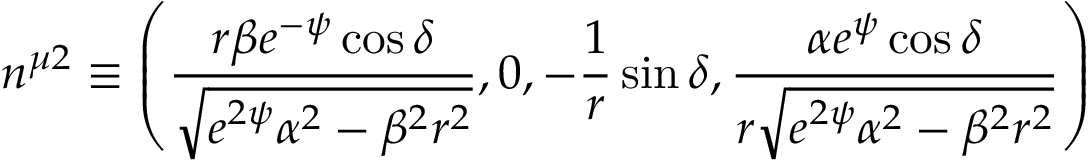Convert formula to latex. <formula><loc_0><loc_0><loc_500><loc_500>n ^ { \mu 2 } \equiv \left ( \frac { r \beta e ^ { - \psi } \cos \delta } { \sqrt { e ^ { 2 \psi } \alpha ^ { 2 } - \beta ^ { 2 } r ^ { 2 } } } , 0 , - \frac { 1 } { r } \sin \delta , \frac { \alpha e ^ { \psi } \cos \delta } { r \sqrt { e ^ { 2 \psi } \alpha ^ { 2 } - \beta ^ { 2 } r ^ { 2 } } } \right )</formula> 